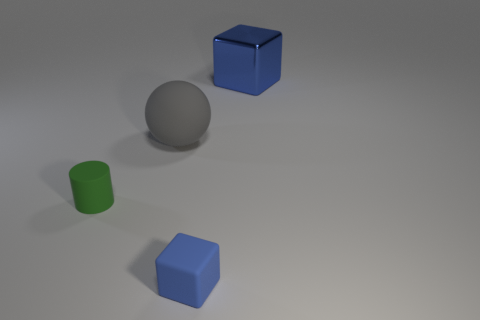Is there a gray ball of the same size as the cylinder?
Provide a succinct answer. No. What is the color of the small rubber object behind the blue cube that is in front of the tiny green cylinder?
Provide a succinct answer. Green. How many red cylinders are there?
Make the answer very short. 0. Does the large cube have the same color as the tiny matte cylinder?
Make the answer very short. No. Is the number of rubber objects that are in front of the large sphere less than the number of tiny matte cubes that are on the left side of the blue matte cube?
Keep it short and to the point. No. The ball has what color?
Offer a very short reply. Gray. How many small rubber cubes have the same color as the cylinder?
Your answer should be compact. 0. There is a big rubber thing; are there any matte cubes on the right side of it?
Your answer should be very brief. Yes. Are there the same number of tiny blue rubber objects that are behind the small green rubber cylinder and blue cubes that are in front of the metal object?
Offer a terse response. No. There is a object on the right side of the small blue rubber object; does it have the same size as the blue object left of the blue metallic object?
Provide a short and direct response. No. 